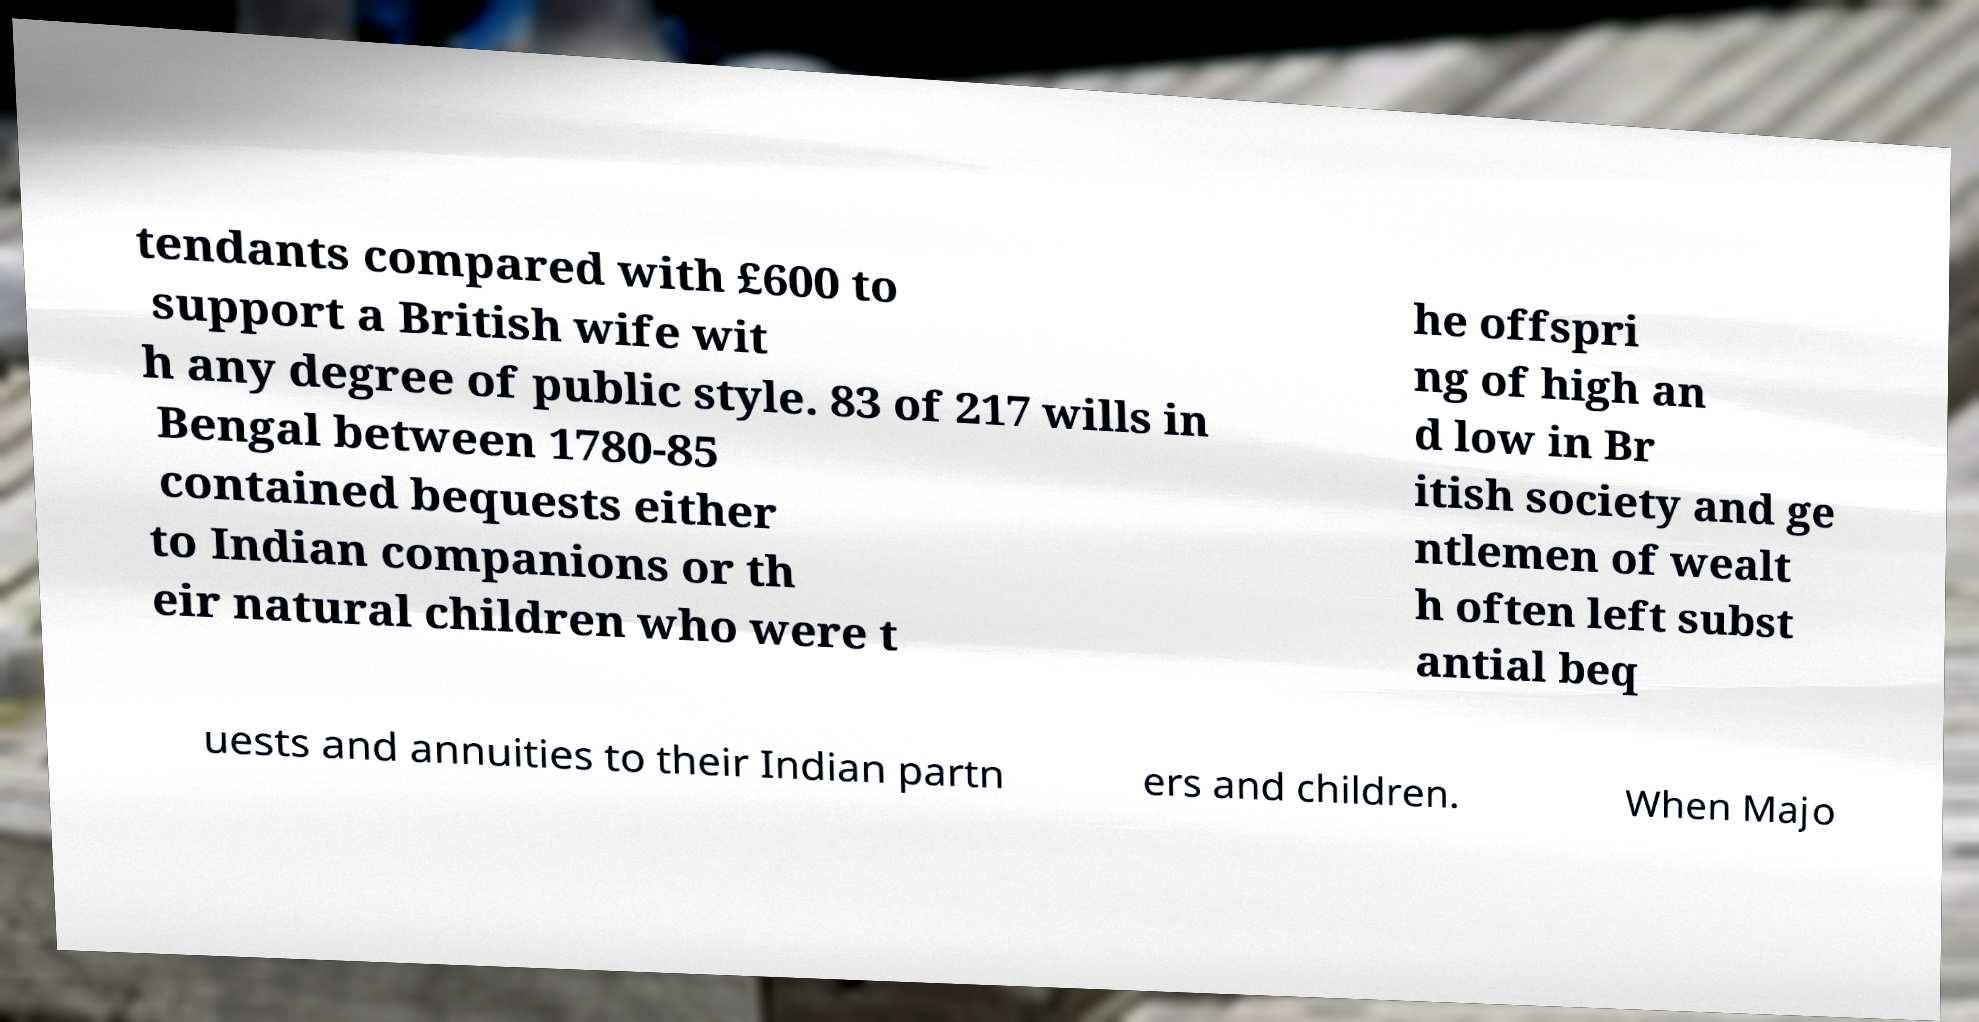Could you extract and type out the text from this image? tendants compared with £600 to support a British wife wit h any degree of public style. 83 of 217 wills in Bengal between 1780-85 contained bequests either to Indian companions or th eir natural children who were t he offspri ng of high an d low in Br itish society and ge ntlemen of wealt h often left subst antial beq uests and annuities to their Indian partn ers and children. When Majo 